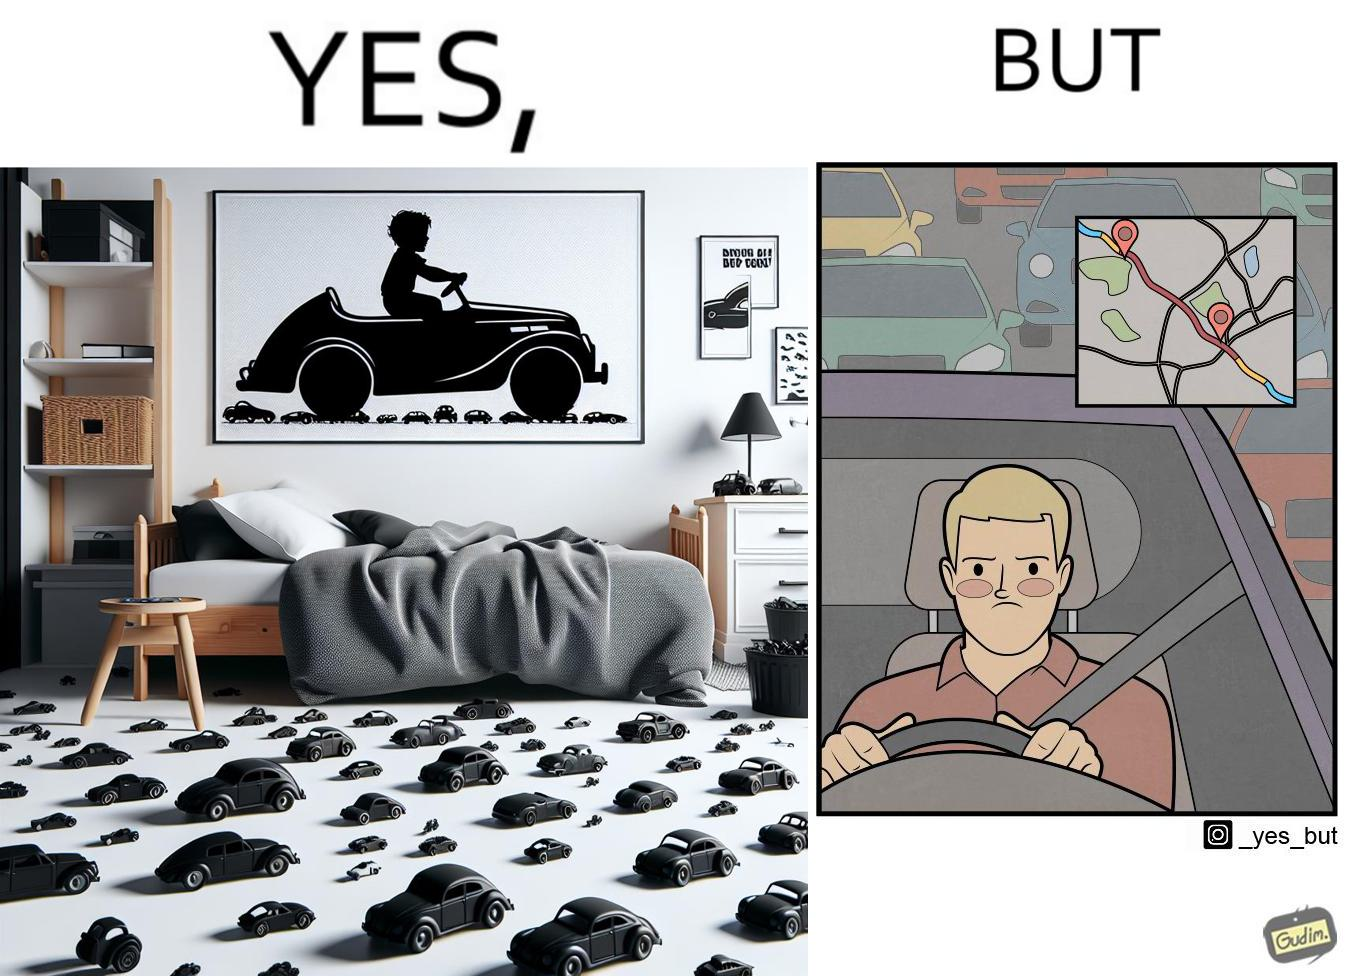Describe the satirical element in this image. The image is funny beaucse while the person as a child enjoyed being around cars, had various small toy cars and even rode a bigger toy car, as as grown up he does not enjoy being in a car during a traffic jam while he is driving . 